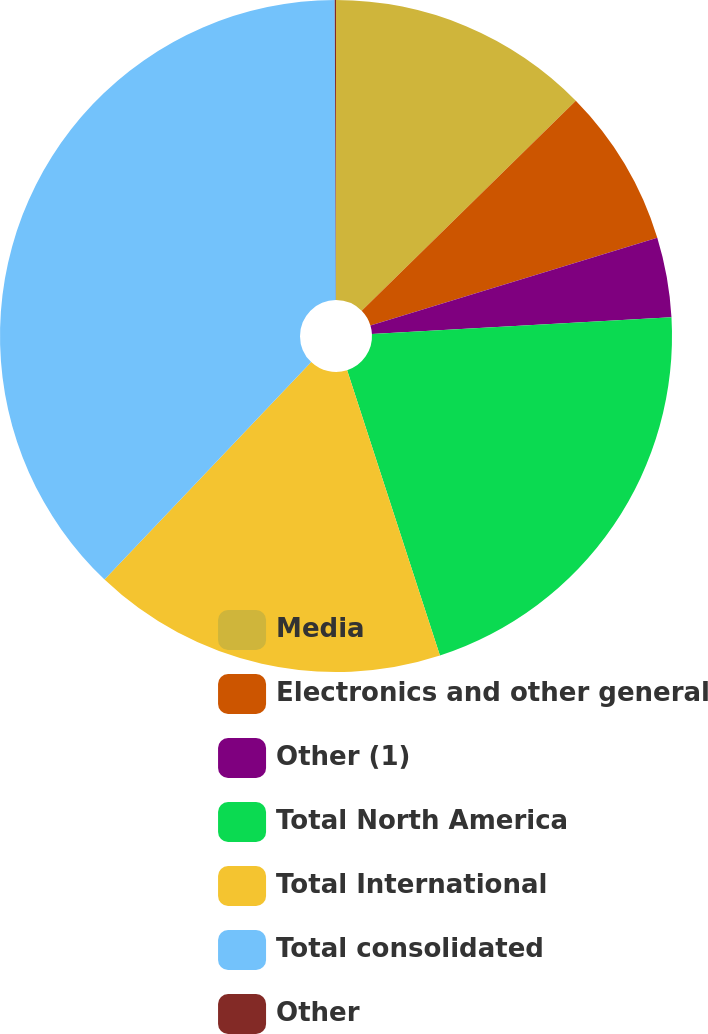Convert chart. <chart><loc_0><loc_0><loc_500><loc_500><pie_chart><fcel>Media<fcel>Electronics and other general<fcel>Other (1)<fcel>Total North America<fcel>Total International<fcel>Total consolidated<fcel>Other<nl><fcel>12.65%<fcel>7.62%<fcel>3.84%<fcel>20.88%<fcel>17.1%<fcel>37.84%<fcel>0.06%<nl></chart> 